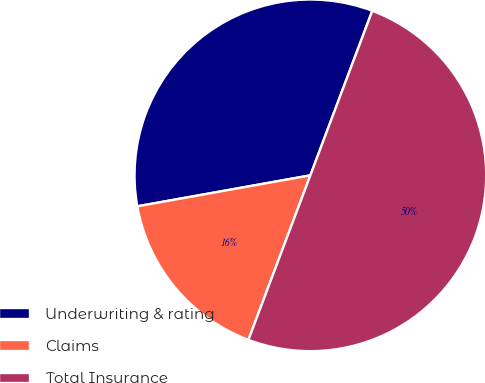Convert chart to OTSL. <chart><loc_0><loc_0><loc_500><loc_500><pie_chart><fcel>Underwriting & rating<fcel>Claims<fcel>Total Insurance<nl><fcel>33.55%<fcel>16.45%<fcel>50.0%<nl></chart> 